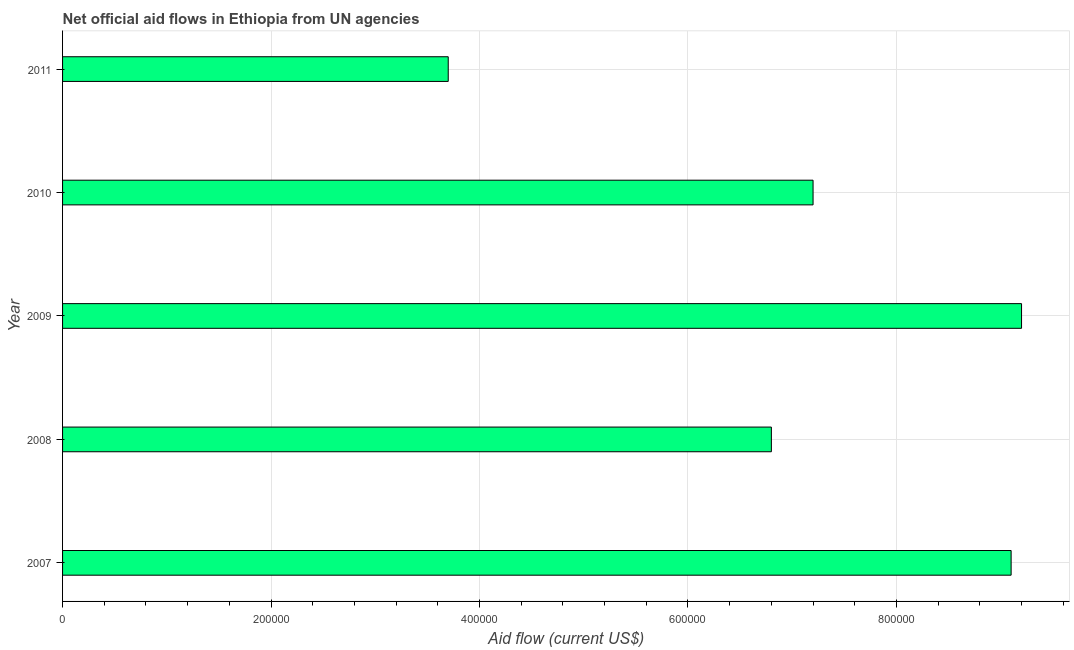Does the graph contain grids?
Your answer should be very brief. Yes. What is the title of the graph?
Your answer should be very brief. Net official aid flows in Ethiopia from UN agencies. What is the label or title of the X-axis?
Provide a short and direct response. Aid flow (current US$). What is the net official flows from un agencies in 2007?
Your response must be concise. 9.10e+05. Across all years, what is the maximum net official flows from un agencies?
Ensure brevity in your answer.  9.20e+05. In which year was the net official flows from un agencies maximum?
Keep it short and to the point. 2009. In which year was the net official flows from un agencies minimum?
Offer a very short reply. 2011. What is the sum of the net official flows from un agencies?
Provide a short and direct response. 3.60e+06. What is the difference between the net official flows from un agencies in 2007 and 2011?
Keep it short and to the point. 5.40e+05. What is the average net official flows from un agencies per year?
Your answer should be very brief. 7.20e+05. What is the median net official flows from un agencies?
Provide a succinct answer. 7.20e+05. Do a majority of the years between 2009 and 2007 (inclusive) have net official flows from un agencies greater than 360000 US$?
Make the answer very short. Yes. What is the ratio of the net official flows from un agencies in 2009 to that in 2011?
Your answer should be compact. 2.49. Is the net official flows from un agencies in 2008 less than that in 2010?
Keep it short and to the point. Yes. What is the difference between the highest and the lowest net official flows from un agencies?
Your answer should be compact. 5.50e+05. Are all the bars in the graph horizontal?
Offer a terse response. Yes. Are the values on the major ticks of X-axis written in scientific E-notation?
Your answer should be very brief. No. What is the Aid flow (current US$) of 2007?
Your answer should be compact. 9.10e+05. What is the Aid flow (current US$) of 2008?
Provide a short and direct response. 6.80e+05. What is the Aid flow (current US$) in 2009?
Your answer should be compact. 9.20e+05. What is the Aid flow (current US$) in 2010?
Give a very brief answer. 7.20e+05. What is the Aid flow (current US$) of 2011?
Offer a very short reply. 3.70e+05. What is the difference between the Aid flow (current US$) in 2007 and 2009?
Ensure brevity in your answer.  -10000. What is the difference between the Aid flow (current US$) in 2007 and 2010?
Offer a very short reply. 1.90e+05. What is the difference between the Aid flow (current US$) in 2007 and 2011?
Keep it short and to the point. 5.40e+05. What is the difference between the Aid flow (current US$) in 2008 and 2011?
Offer a terse response. 3.10e+05. What is the difference between the Aid flow (current US$) in 2009 and 2010?
Your response must be concise. 2.00e+05. What is the difference between the Aid flow (current US$) in 2009 and 2011?
Provide a succinct answer. 5.50e+05. What is the difference between the Aid flow (current US$) in 2010 and 2011?
Ensure brevity in your answer.  3.50e+05. What is the ratio of the Aid flow (current US$) in 2007 to that in 2008?
Your answer should be very brief. 1.34. What is the ratio of the Aid flow (current US$) in 2007 to that in 2009?
Your answer should be very brief. 0.99. What is the ratio of the Aid flow (current US$) in 2007 to that in 2010?
Give a very brief answer. 1.26. What is the ratio of the Aid flow (current US$) in 2007 to that in 2011?
Ensure brevity in your answer.  2.46. What is the ratio of the Aid flow (current US$) in 2008 to that in 2009?
Your answer should be compact. 0.74. What is the ratio of the Aid flow (current US$) in 2008 to that in 2010?
Make the answer very short. 0.94. What is the ratio of the Aid flow (current US$) in 2008 to that in 2011?
Your answer should be very brief. 1.84. What is the ratio of the Aid flow (current US$) in 2009 to that in 2010?
Provide a short and direct response. 1.28. What is the ratio of the Aid flow (current US$) in 2009 to that in 2011?
Your answer should be compact. 2.49. What is the ratio of the Aid flow (current US$) in 2010 to that in 2011?
Your response must be concise. 1.95. 